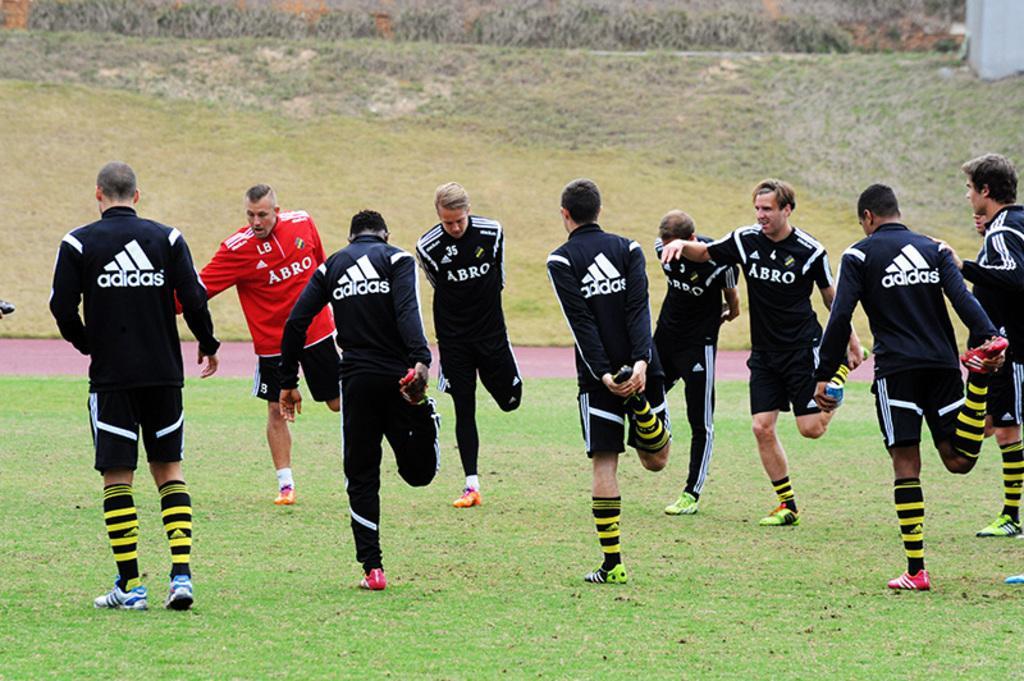How would you summarize this image in a sentence or two? In this image we can able to see a group of people standing on the ground, and some of them are holding their legs with their hands, and there is a guy who is wearing red color t-shirt and there is an ARBOR on his t-shirt and most of them are wearing black color t-shirts and there is adidas sign on their t-shirts. 